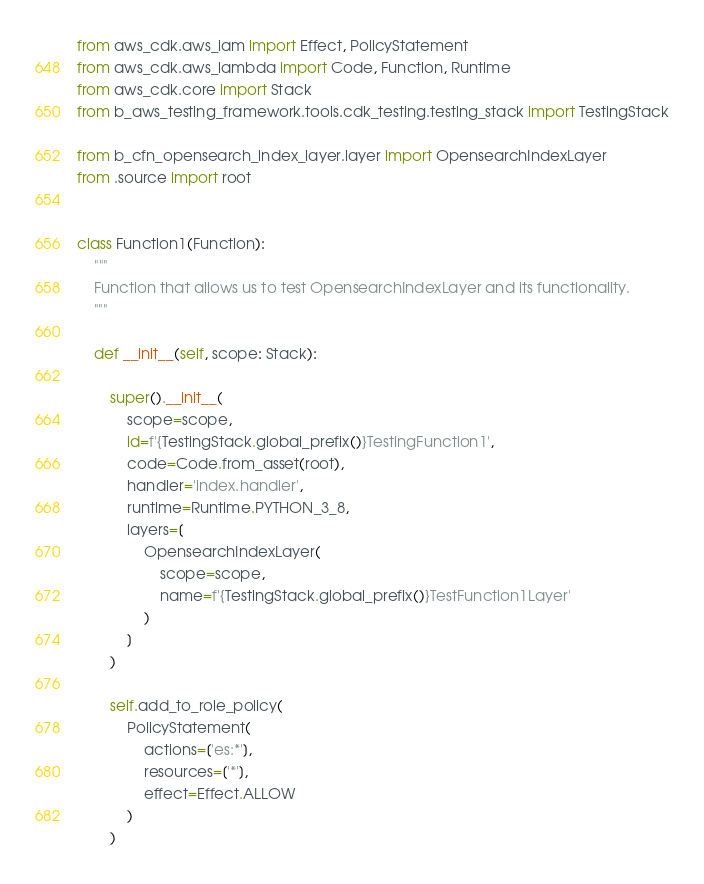Convert code to text. <code><loc_0><loc_0><loc_500><loc_500><_Python_>from aws_cdk.aws_iam import Effect, PolicyStatement
from aws_cdk.aws_lambda import Code, Function, Runtime
from aws_cdk.core import Stack
from b_aws_testing_framework.tools.cdk_testing.testing_stack import TestingStack

from b_cfn_opensearch_index_layer.layer import OpensearchIndexLayer
from .source import root


class Function1(Function):
    """
    Function that allows us to test OpensearchIndexLayer and its functionality.
    """

    def __init__(self, scope: Stack):

        super().__init__(
            scope=scope,
            id=f'{TestingStack.global_prefix()}TestingFunction1',
            code=Code.from_asset(root),
            handler='index.handler',
            runtime=Runtime.PYTHON_3_8,
            layers=[
                OpensearchIndexLayer(
                    scope=scope,
                    name=f'{TestingStack.global_prefix()}TestFunction1Layer'
                )
            ]
        )

        self.add_to_role_policy(
            PolicyStatement(
                actions=['es:*'],
                resources=['*'],
                effect=Effect.ALLOW
            )
        )
</code> 